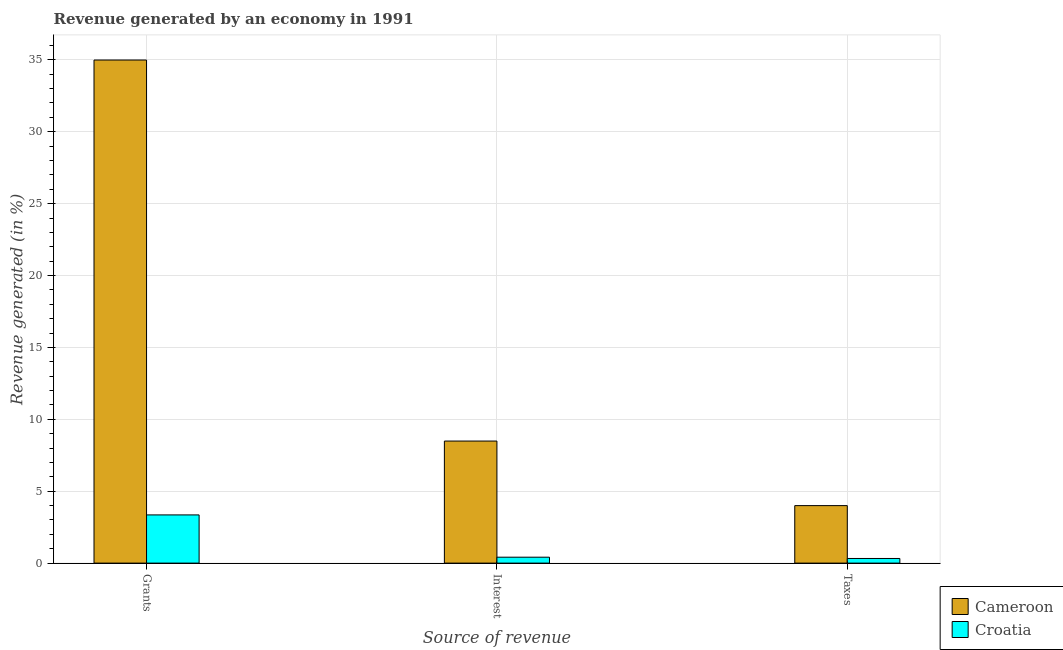How many different coloured bars are there?
Your answer should be compact. 2. Are the number of bars per tick equal to the number of legend labels?
Your answer should be compact. Yes. How many bars are there on the 3rd tick from the right?
Make the answer very short. 2. What is the label of the 3rd group of bars from the left?
Ensure brevity in your answer.  Taxes. What is the percentage of revenue generated by grants in Cameroon?
Your answer should be very brief. 34.99. Across all countries, what is the maximum percentage of revenue generated by taxes?
Provide a succinct answer. 4. Across all countries, what is the minimum percentage of revenue generated by interest?
Give a very brief answer. 0.41. In which country was the percentage of revenue generated by grants maximum?
Give a very brief answer. Cameroon. In which country was the percentage of revenue generated by grants minimum?
Your answer should be very brief. Croatia. What is the total percentage of revenue generated by taxes in the graph?
Ensure brevity in your answer.  4.32. What is the difference between the percentage of revenue generated by grants in Croatia and that in Cameroon?
Give a very brief answer. -31.63. What is the difference between the percentage of revenue generated by taxes in Cameroon and the percentage of revenue generated by interest in Croatia?
Offer a very short reply. 3.59. What is the average percentage of revenue generated by taxes per country?
Offer a very short reply. 2.16. What is the difference between the percentage of revenue generated by interest and percentage of revenue generated by taxes in Cameroon?
Make the answer very short. 4.49. What is the ratio of the percentage of revenue generated by grants in Cameroon to that in Croatia?
Provide a short and direct response. 10.44. Is the difference between the percentage of revenue generated by taxes in Cameroon and Croatia greater than the difference between the percentage of revenue generated by interest in Cameroon and Croatia?
Provide a succinct answer. No. What is the difference between the highest and the second highest percentage of revenue generated by interest?
Give a very brief answer. 8.08. What is the difference between the highest and the lowest percentage of revenue generated by taxes?
Your answer should be very brief. 3.68. What does the 2nd bar from the left in Interest represents?
Keep it short and to the point. Croatia. What does the 2nd bar from the right in Taxes represents?
Offer a very short reply. Cameroon. Are all the bars in the graph horizontal?
Make the answer very short. No. How many countries are there in the graph?
Provide a succinct answer. 2. What is the difference between two consecutive major ticks on the Y-axis?
Your response must be concise. 5. Does the graph contain any zero values?
Provide a succinct answer. No. Does the graph contain grids?
Your answer should be compact. Yes. Where does the legend appear in the graph?
Offer a terse response. Bottom right. How are the legend labels stacked?
Your answer should be very brief. Vertical. What is the title of the graph?
Provide a short and direct response. Revenue generated by an economy in 1991. What is the label or title of the X-axis?
Provide a short and direct response. Source of revenue. What is the label or title of the Y-axis?
Make the answer very short. Revenue generated (in %). What is the Revenue generated (in %) of Cameroon in Grants?
Offer a very short reply. 34.99. What is the Revenue generated (in %) of Croatia in Grants?
Your answer should be compact. 3.35. What is the Revenue generated (in %) in Cameroon in Interest?
Provide a succinct answer. 8.49. What is the Revenue generated (in %) in Croatia in Interest?
Provide a short and direct response. 0.41. What is the Revenue generated (in %) in Cameroon in Taxes?
Make the answer very short. 4. What is the Revenue generated (in %) of Croatia in Taxes?
Give a very brief answer. 0.32. Across all Source of revenue, what is the maximum Revenue generated (in %) in Cameroon?
Give a very brief answer. 34.99. Across all Source of revenue, what is the maximum Revenue generated (in %) of Croatia?
Provide a short and direct response. 3.35. Across all Source of revenue, what is the minimum Revenue generated (in %) of Cameroon?
Provide a short and direct response. 4. Across all Source of revenue, what is the minimum Revenue generated (in %) in Croatia?
Your answer should be compact. 0.32. What is the total Revenue generated (in %) in Cameroon in the graph?
Your response must be concise. 47.47. What is the total Revenue generated (in %) in Croatia in the graph?
Your response must be concise. 4.09. What is the difference between the Revenue generated (in %) of Cameroon in Grants and that in Interest?
Your answer should be very brief. 26.5. What is the difference between the Revenue generated (in %) in Croatia in Grants and that in Interest?
Give a very brief answer. 2.94. What is the difference between the Revenue generated (in %) in Cameroon in Grants and that in Taxes?
Your answer should be compact. 30.99. What is the difference between the Revenue generated (in %) of Croatia in Grants and that in Taxes?
Make the answer very short. 3.03. What is the difference between the Revenue generated (in %) of Cameroon in Interest and that in Taxes?
Keep it short and to the point. 4.49. What is the difference between the Revenue generated (in %) in Croatia in Interest and that in Taxes?
Offer a very short reply. 0.09. What is the difference between the Revenue generated (in %) in Cameroon in Grants and the Revenue generated (in %) in Croatia in Interest?
Keep it short and to the point. 34.57. What is the difference between the Revenue generated (in %) of Cameroon in Grants and the Revenue generated (in %) of Croatia in Taxes?
Offer a very short reply. 34.66. What is the difference between the Revenue generated (in %) in Cameroon in Interest and the Revenue generated (in %) in Croatia in Taxes?
Provide a short and direct response. 8.17. What is the average Revenue generated (in %) of Cameroon per Source of revenue?
Your answer should be very brief. 15.82. What is the average Revenue generated (in %) in Croatia per Source of revenue?
Offer a terse response. 1.36. What is the difference between the Revenue generated (in %) in Cameroon and Revenue generated (in %) in Croatia in Grants?
Your response must be concise. 31.63. What is the difference between the Revenue generated (in %) in Cameroon and Revenue generated (in %) in Croatia in Interest?
Ensure brevity in your answer.  8.08. What is the difference between the Revenue generated (in %) in Cameroon and Revenue generated (in %) in Croatia in Taxes?
Offer a very short reply. 3.68. What is the ratio of the Revenue generated (in %) in Cameroon in Grants to that in Interest?
Ensure brevity in your answer.  4.12. What is the ratio of the Revenue generated (in %) of Croatia in Grants to that in Interest?
Provide a short and direct response. 8.13. What is the ratio of the Revenue generated (in %) in Cameroon in Grants to that in Taxes?
Provide a short and direct response. 8.75. What is the ratio of the Revenue generated (in %) of Croatia in Grants to that in Taxes?
Keep it short and to the point. 10.38. What is the ratio of the Revenue generated (in %) of Cameroon in Interest to that in Taxes?
Keep it short and to the point. 2.12. What is the ratio of the Revenue generated (in %) of Croatia in Interest to that in Taxes?
Keep it short and to the point. 1.28. What is the difference between the highest and the second highest Revenue generated (in %) of Cameroon?
Offer a terse response. 26.5. What is the difference between the highest and the second highest Revenue generated (in %) in Croatia?
Your answer should be compact. 2.94. What is the difference between the highest and the lowest Revenue generated (in %) in Cameroon?
Give a very brief answer. 30.99. What is the difference between the highest and the lowest Revenue generated (in %) in Croatia?
Provide a short and direct response. 3.03. 